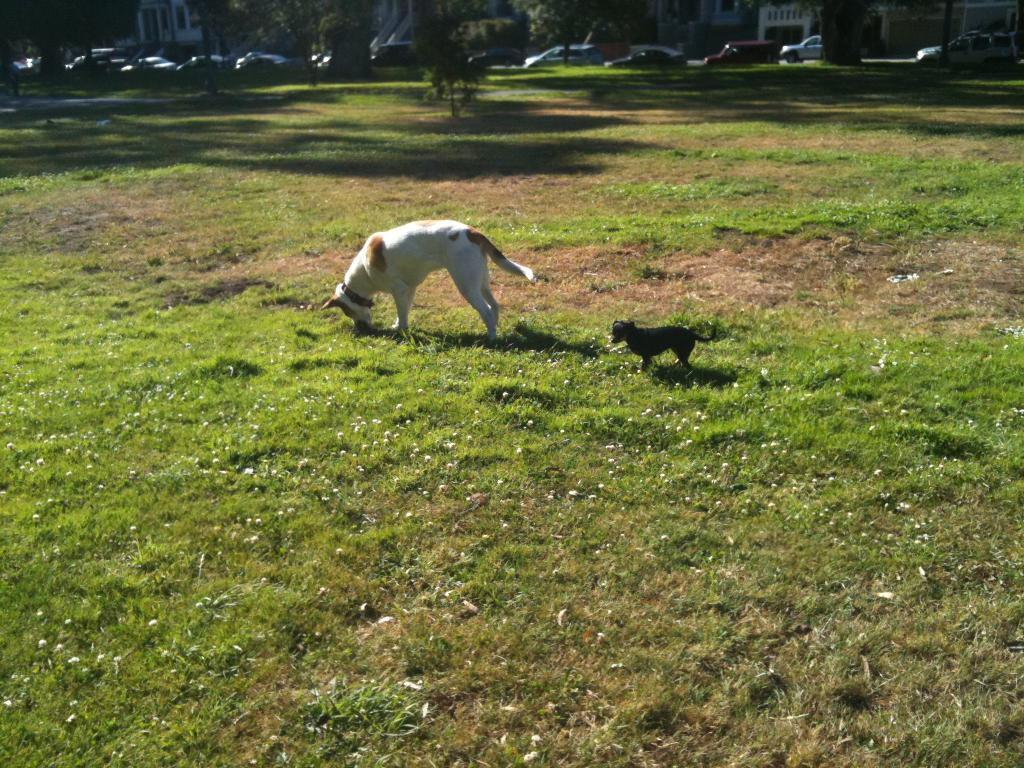What animals are in the center of the image? There are dogs in the center of the image. What type of terrain is visible at the bottom of the image? There is grass at the bottom of the image. What can be seen in the distance behind the dogs? There are cars, trees, and buildings in the background of the image. What type of thunder can be heard in the image? There is no thunder present in the image, as it is a visual medium and does not contain sound. 